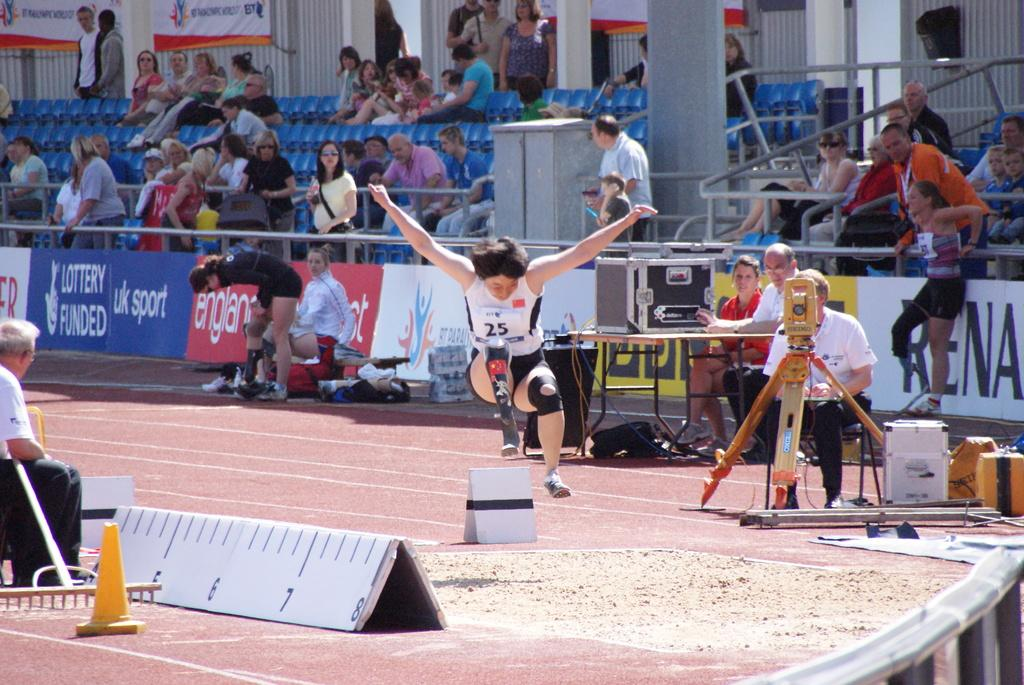<image>
Share a concise interpretation of the image provided. uk sport is one of the sponsors of the event shown here 